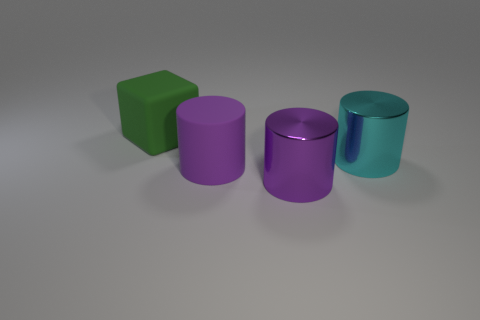How many purple cylinders must be subtracted to get 1 purple cylinders? 1 Subtract all large purple rubber cylinders. How many cylinders are left? 2 Add 1 large gray spheres. How many objects exist? 5 Subtract all blue blocks. How many purple cylinders are left? 2 Subtract all purple cylinders. How many cylinders are left? 1 Subtract all blocks. How many objects are left? 3 Subtract 1 purple cylinders. How many objects are left? 3 Subtract all blue cylinders. Subtract all blue spheres. How many cylinders are left? 3 Subtract all big green rubber cubes. Subtract all large matte cylinders. How many objects are left? 2 Add 2 green blocks. How many green blocks are left? 3 